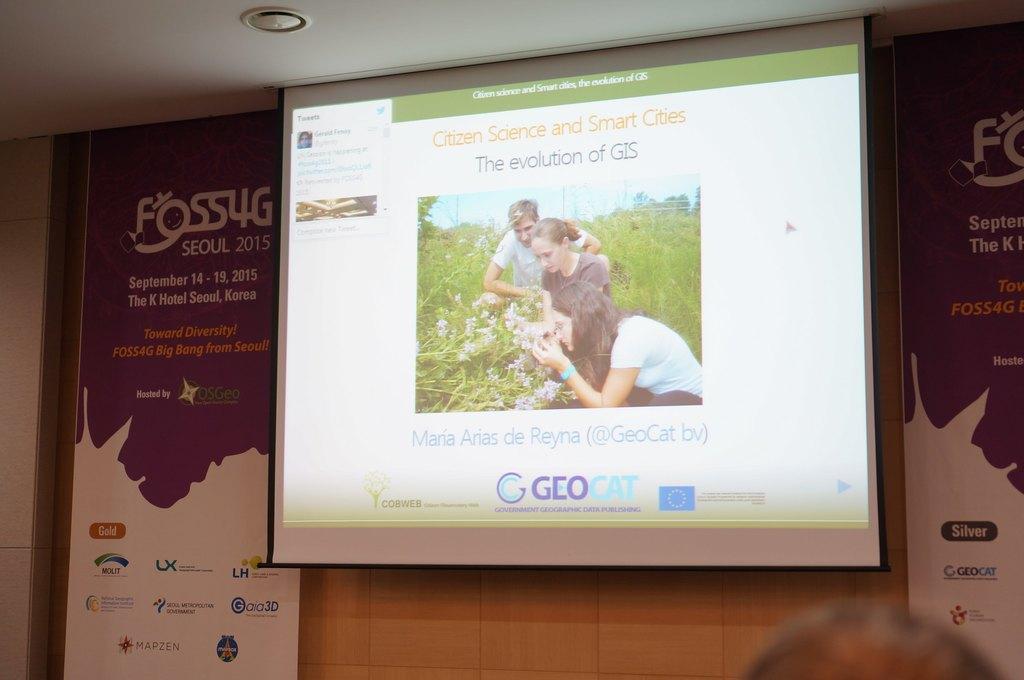Could you give a brief overview of what you see in this image? In this picture we can see hoardings on the right side and left side, there is a projector screen in the middle, we can see a picture and some text on the screen, in this picture we can see three persons. some plants, flowers and the sky, at the right bottom we can see a person's head. 